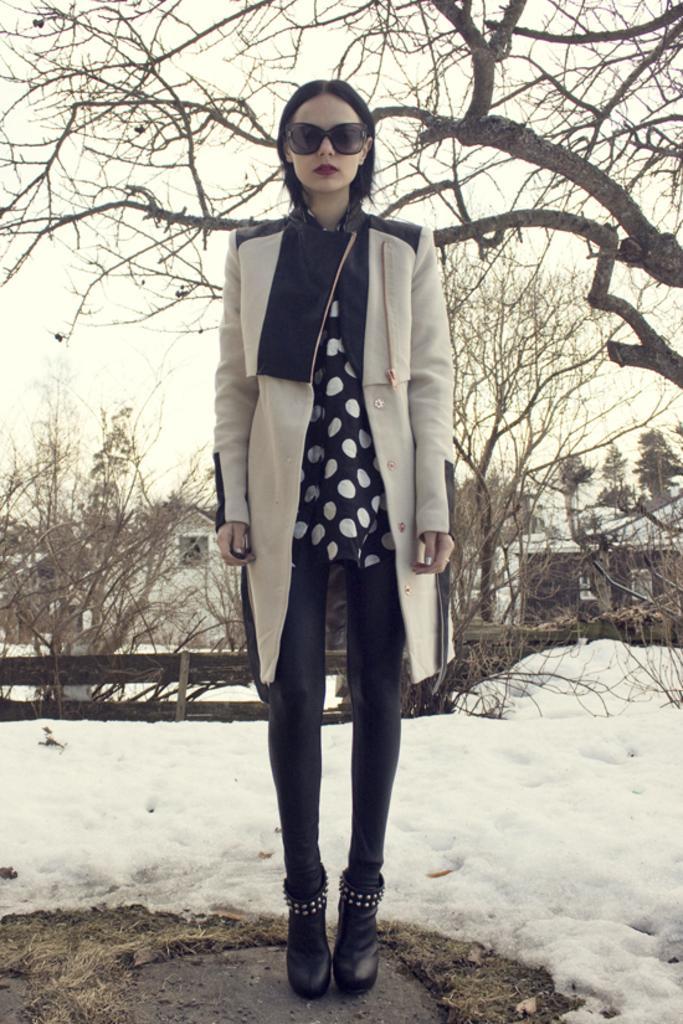How would you summarize this image in a sentence or two? In this picture we can see a woman is standing in the front, there is snow at the bottom, we can see trees in the middle, in the background there are houses, we can see the sky at the top of the picture. 